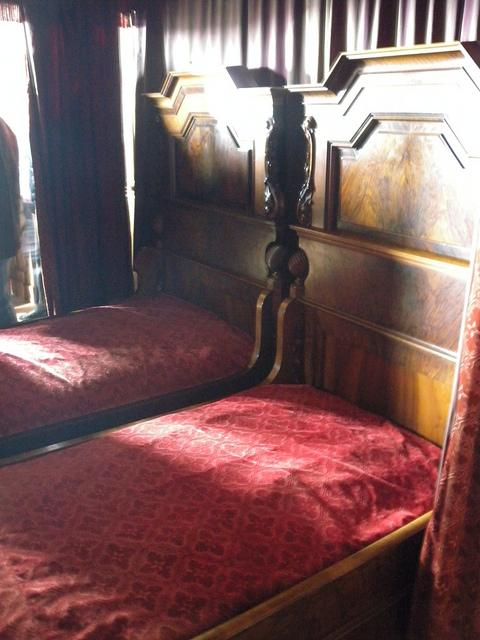What are the two areas decorated with red sheets used for? sleeping 